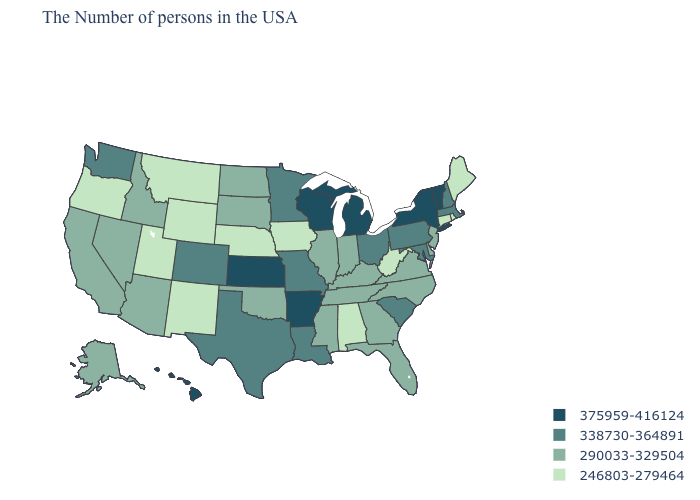Is the legend a continuous bar?
Short answer required. No. Name the states that have a value in the range 246803-279464?
Keep it brief. Maine, Rhode Island, Connecticut, West Virginia, Alabama, Iowa, Nebraska, Wyoming, New Mexico, Utah, Montana, Oregon. Among the states that border New Hampshire , does Vermont have the lowest value?
Short answer required. No. What is the lowest value in states that border Colorado?
Keep it brief. 246803-279464. What is the value of Mississippi?
Quick response, please. 290033-329504. What is the value of Virginia?
Short answer required. 290033-329504. Among the states that border New Mexico , which have the lowest value?
Give a very brief answer. Utah. What is the value of Wyoming?
Quick response, please. 246803-279464. Does the map have missing data?
Short answer required. No. Does Kentucky have the same value as Virginia?
Short answer required. Yes. How many symbols are there in the legend?
Answer briefly. 4. What is the value of Arizona?
Short answer required. 290033-329504. Among the states that border Massachusetts , which have the lowest value?
Quick response, please. Rhode Island, Connecticut. Among the states that border Virginia , does Kentucky have the lowest value?
Be succinct. No. What is the lowest value in the West?
Give a very brief answer. 246803-279464. 